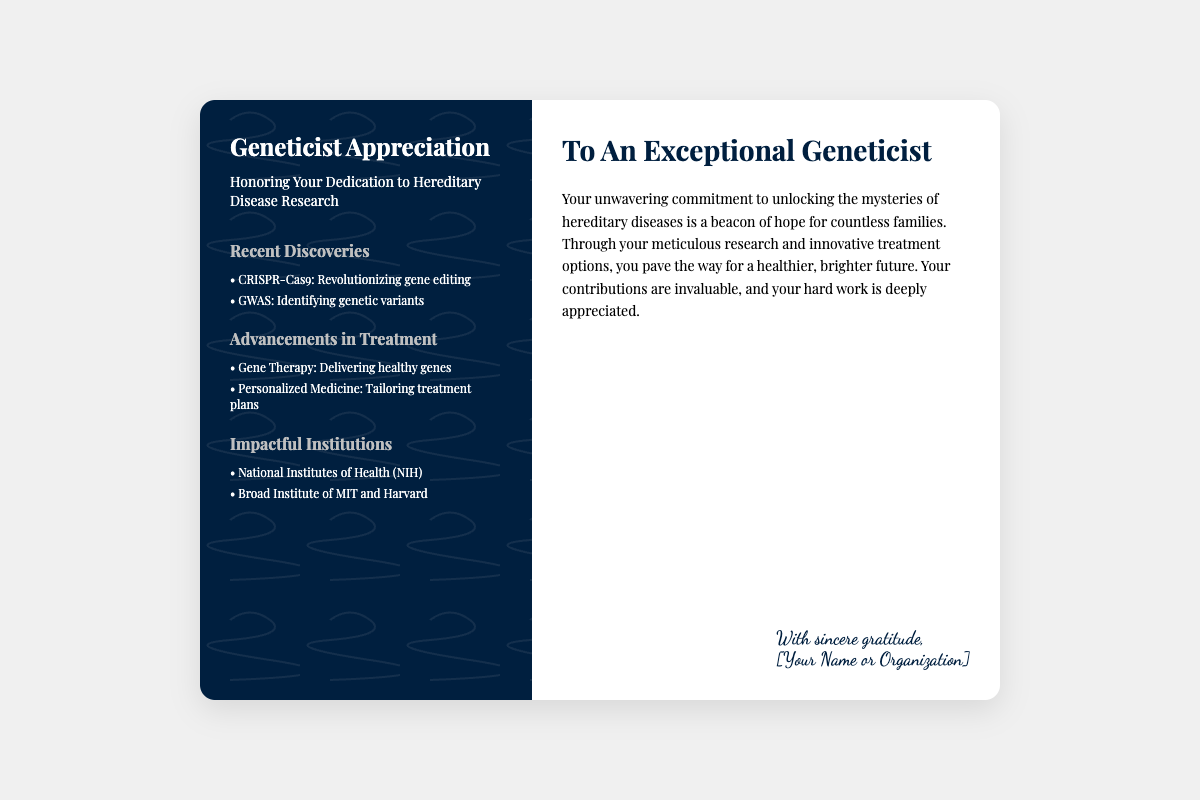What is the title of the card? The title of the card is prominently displayed at the top left of the document, which expresses the theme of the card.
Answer: Geneticist Appreciation What are two recent discoveries mentioned? The document lists recent discoveries under the highlights section, specifically focusing on advancements in genetic research.
Answer: CRISPR-Cas9, GWAS What type of therapy is highlighted for advancements in treatment? The document specifically mentions the category of therapy that delivers healthy genes as a treatment option.
Answer: Gene Therapy Who is the card addressed to? The header section indicates the recipient of the appreciation, which reflects the focus of the card.
Answer: An Exceptional Geneticist What is the color scheme of the left panel? The left panel is designed with a specific color that contrasts with the text for better readability and aesthetic appeal.
Answer: Dark blue How does the card describe the geneticist's work? The body text elaborates on the impact and value of the geneticist's work, reflecting the card's intent to show appreciation.
Answer: Beacon of hope What is the font used for the footer? The footer of the card utilizes a specific font style that adds a personal touch to the message.
Answer: Dancing Script Which institutions are mentioned for their impact? The highlights section lists specific institutions that contribute to the field of hereditary diseases.
Answer: NIH, Broad Institute of MIT and Harvard 